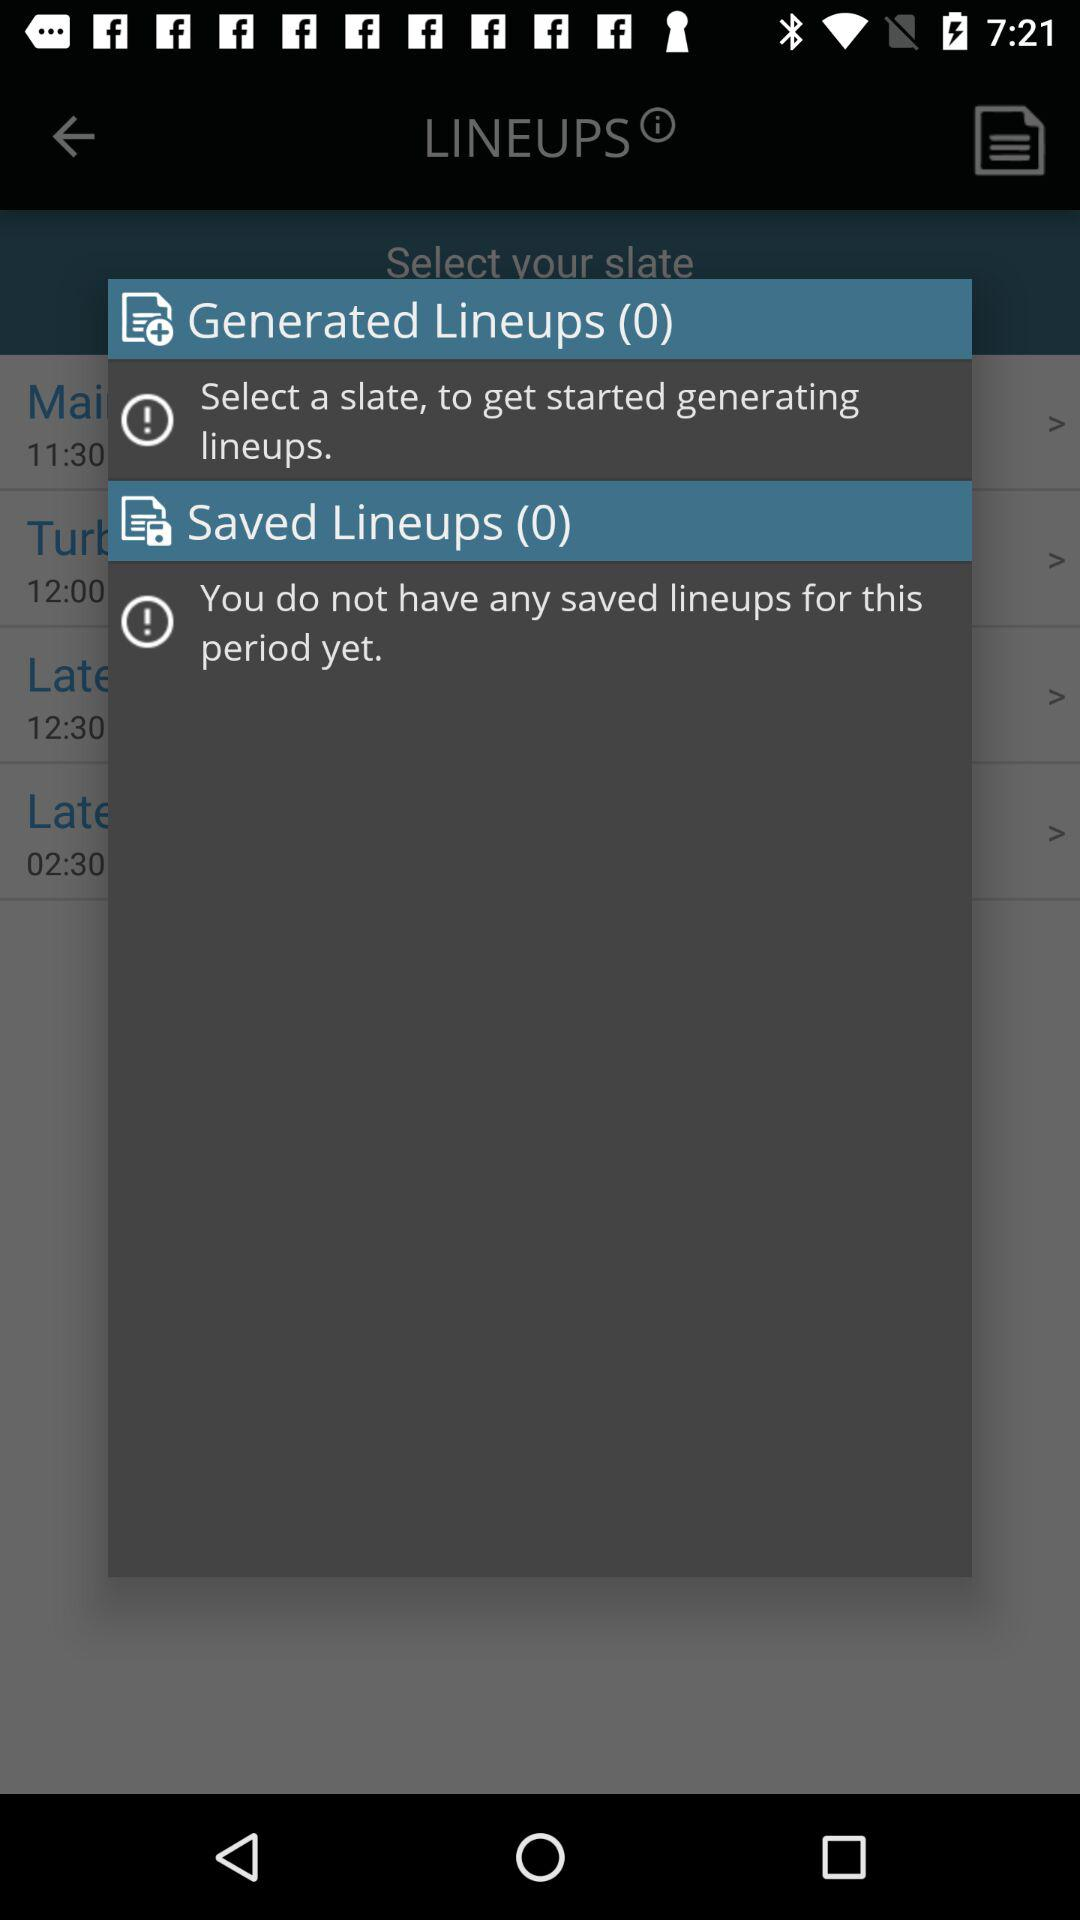What is the total number of saved lineups? There are 0 saved lineups. 